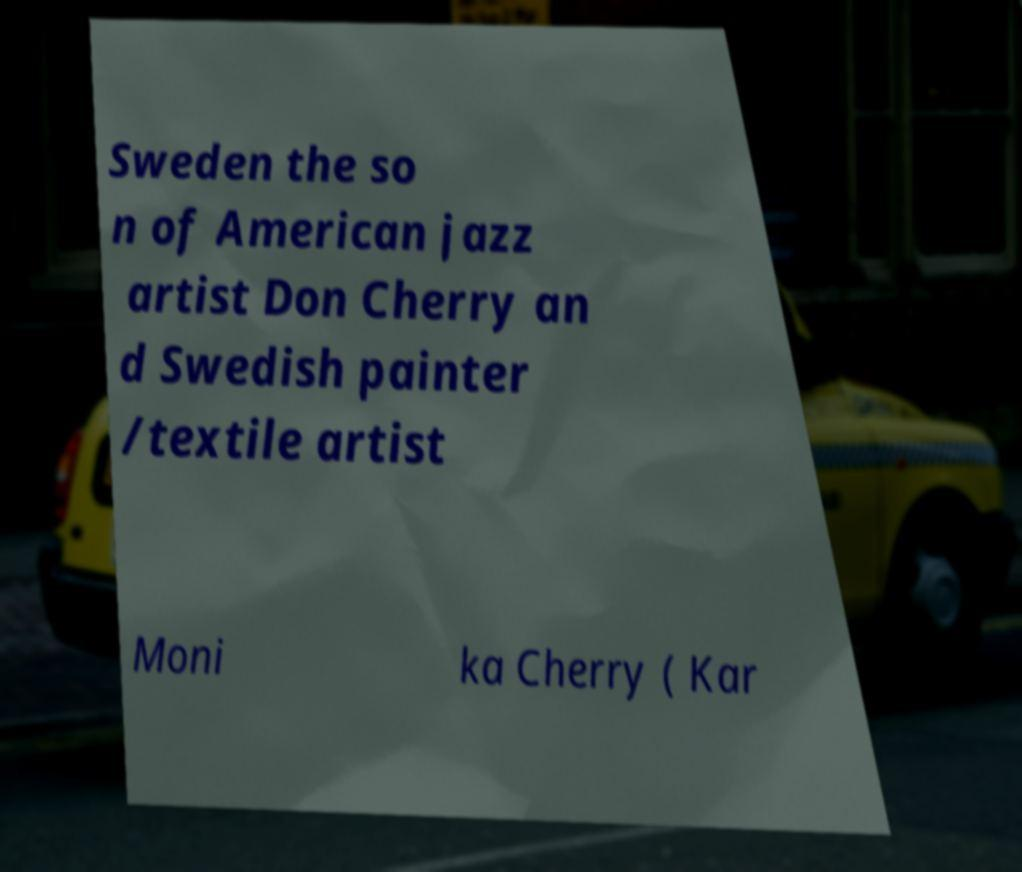Please read and relay the text visible in this image. What does it say? Sweden the so n of American jazz artist Don Cherry an d Swedish painter /textile artist Moni ka Cherry ( Kar 